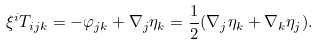Convert formula to latex. <formula><loc_0><loc_0><loc_500><loc_500>\xi ^ { i } T _ { i j k } = - \varphi _ { j k } + \nabla _ { j } \eta _ { k } = \frac { 1 } { 2 } ( \nabla _ { j } \eta _ { k } + \nabla _ { k } \eta _ { j } ) .</formula> 